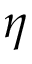<formula> <loc_0><loc_0><loc_500><loc_500>\eta</formula> 